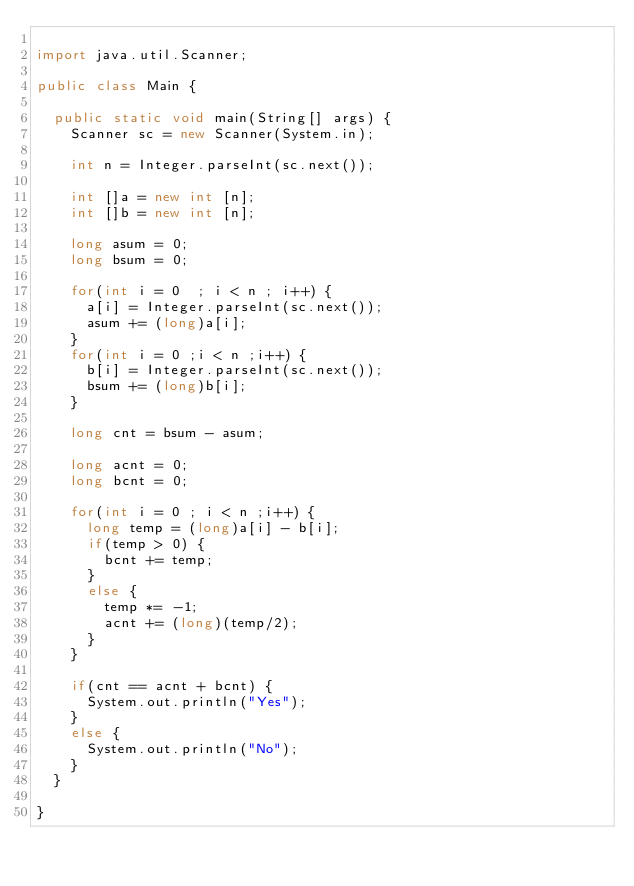Convert code to text. <code><loc_0><loc_0><loc_500><loc_500><_Java_>
import java.util.Scanner;

public class Main {

	public static void main(String[] args) {
		Scanner sc = new Scanner(System.in);
		
		int n = Integer.parseInt(sc.next());
		
		int []a = new int [n];
		int []b = new int [n];
		
		long asum = 0;
		long bsum = 0;
		
		for(int i = 0  ; i < n ; i++) {
			a[i] = Integer.parseInt(sc.next());
			asum += (long)a[i];
		}
		for(int i = 0 ;i < n ;i++) {
			b[i] = Integer.parseInt(sc.next());
			bsum += (long)b[i];
		}
		
		long cnt = bsum - asum;
		
		long acnt = 0;
		long bcnt = 0;
		
		for(int i = 0 ; i < n ;i++) {
			long temp = (long)a[i] - b[i];
			if(temp > 0) {
				bcnt += temp;
			}
			else {
				temp *= -1;
				acnt += (long)(temp/2);
			}
		}
		
		if(cnt == acnt + bcnt) {
			System.out.println("Yes");
		}
		else {
			System.out.println("No");
		}
	}

}
</code> 